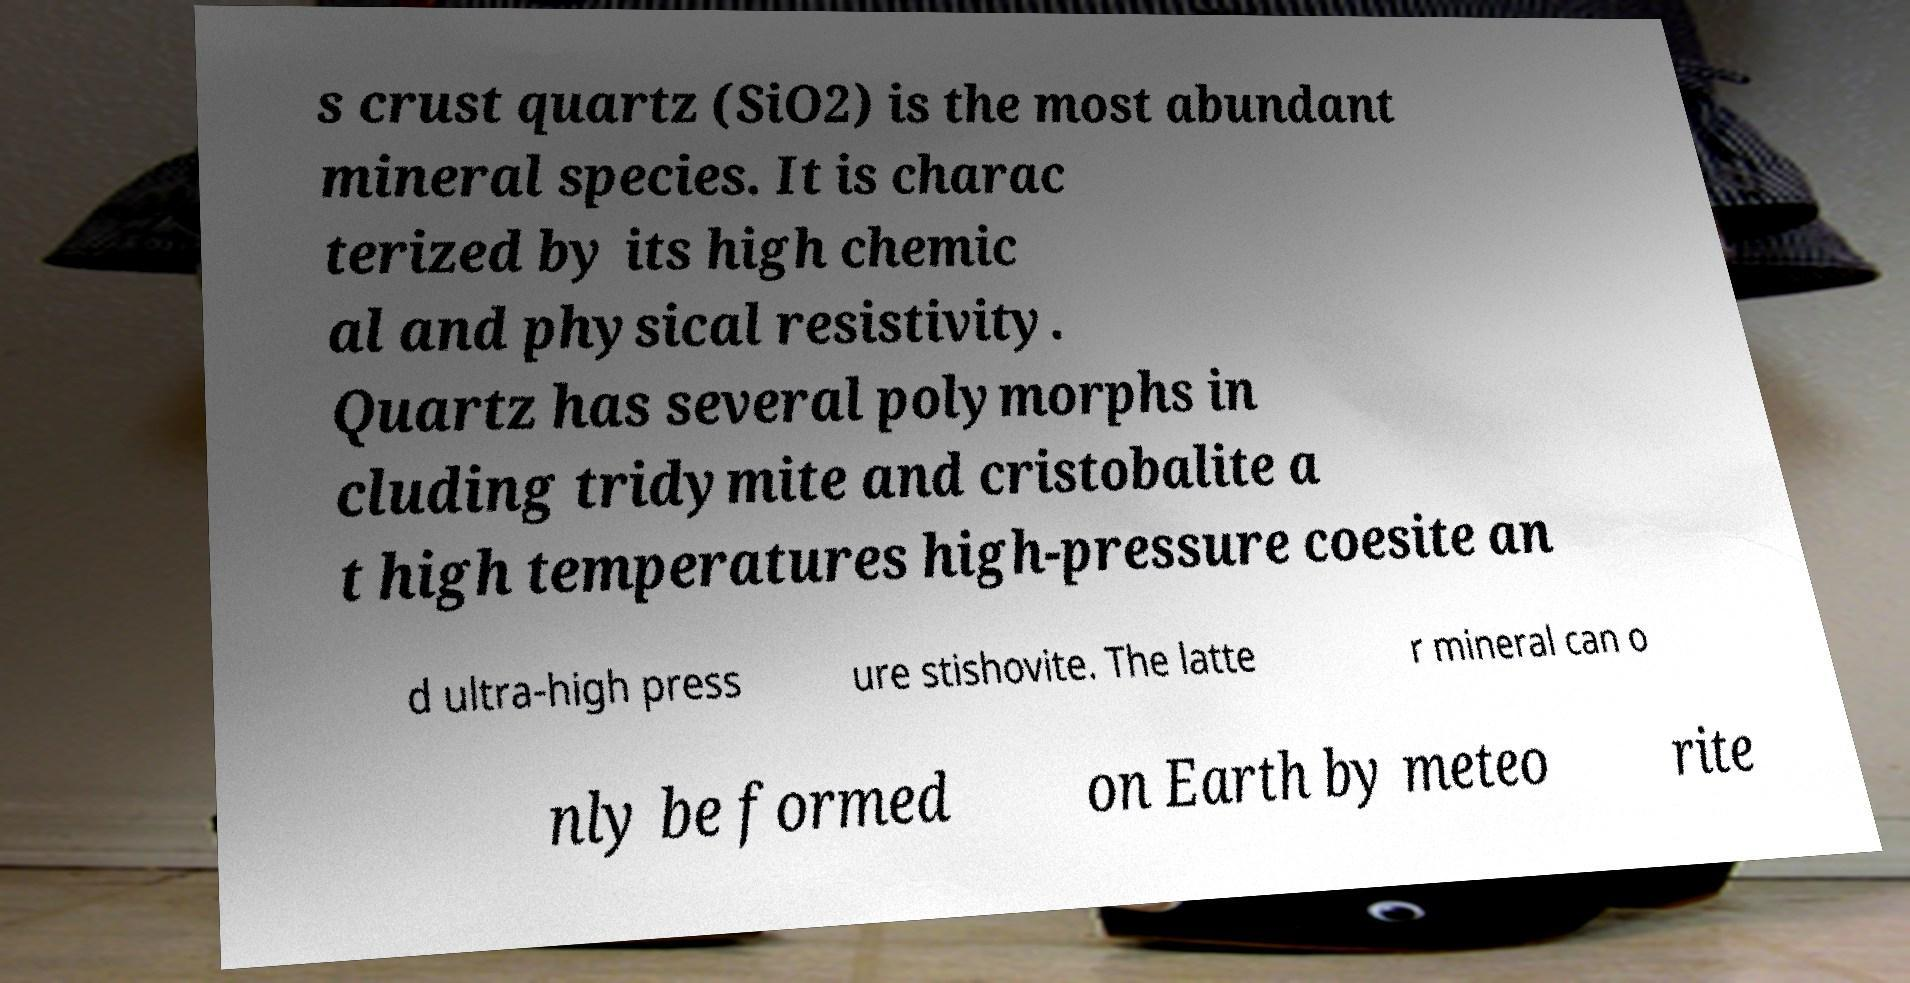Please identify and transcribe the text found in this image. s crust quartz (SiO2) is the most abundant mineral species. It is charac terized by its high chemic al and physical resistivity. Quartz has several polymorphs in cluding tridymite and cristobalite a t high temperatures high-pressure coesite an d ultra-high press ure stishovite. The latte r mineral can o nly be formed on Earth by meteo rite 